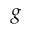Convert formula to latex. <formula><loc_0><loc_0><loc_500><loc_500>g</formula> 